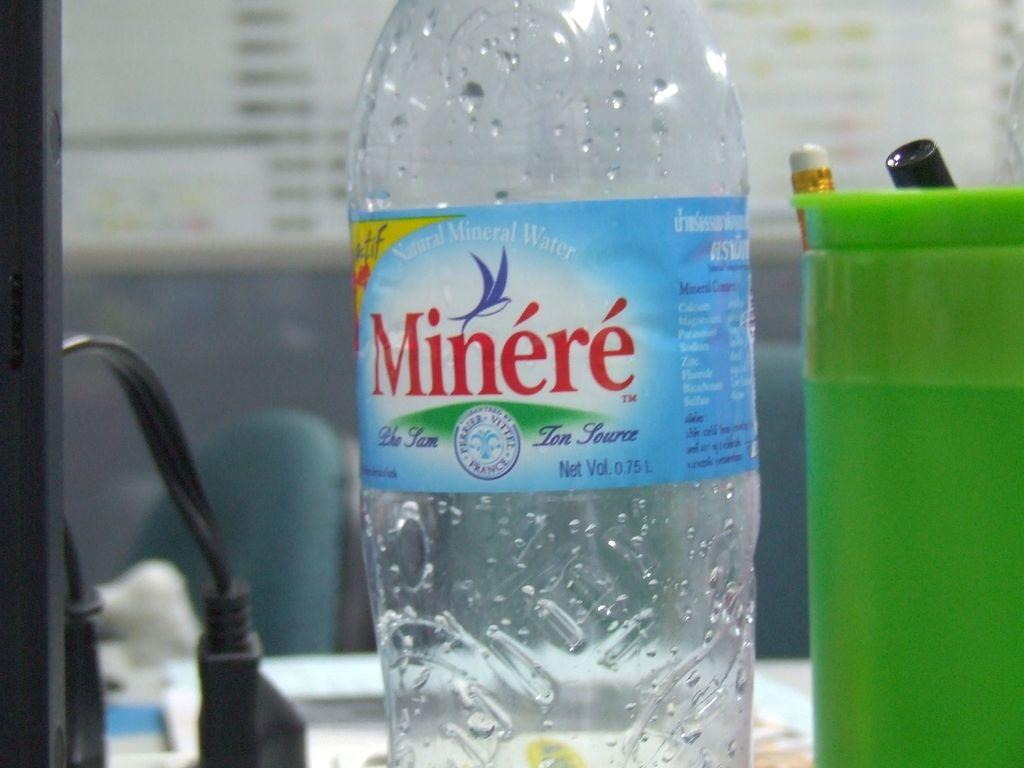<image>
Render a clear and concise summary of the photo. Empty Minere water bottle next to a green cup. 